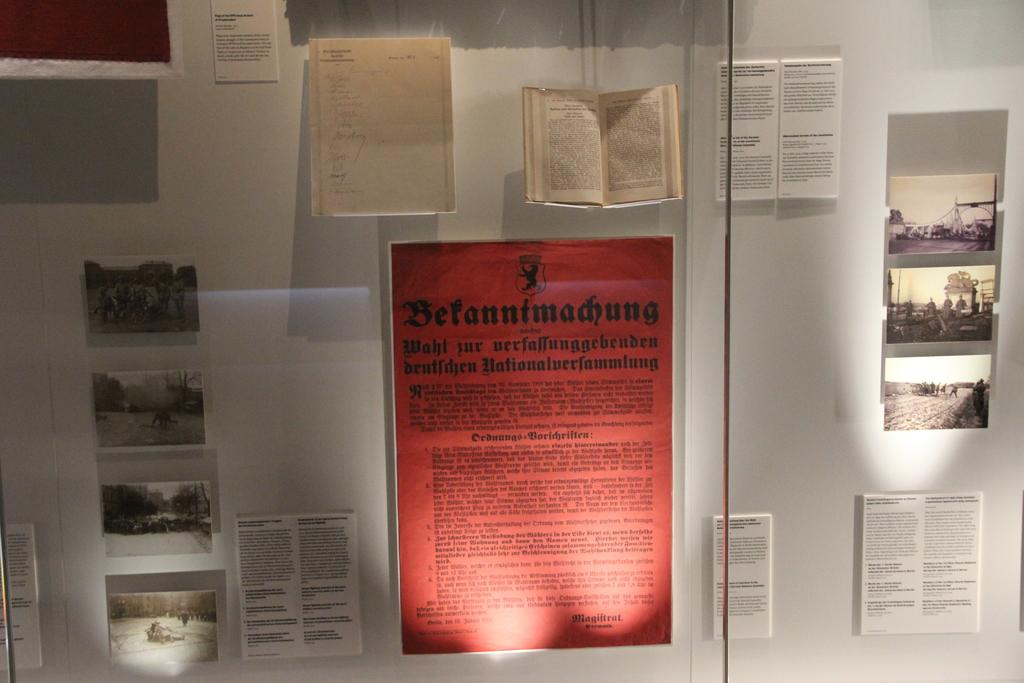<image>
Describe the image concisely. Red paper on a wall titled "Betanntmadhung" for display. 